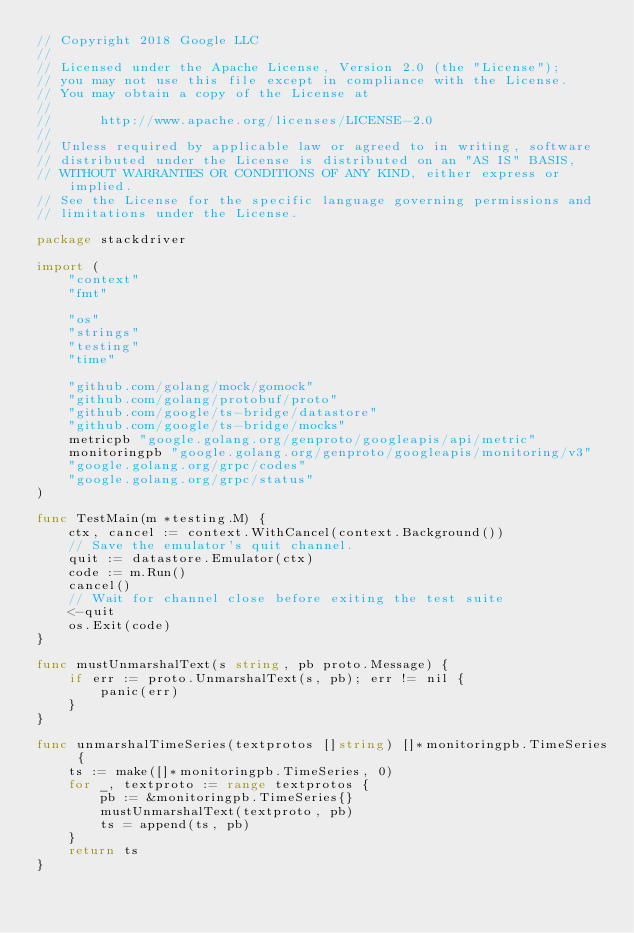<code> <loc_0><loc_0><loc_500><loc_500><_Go_>// Copyright 2018 Google LLC
//
// Licensed under the Apache License, Version 2.0 (the "License");
// you may not use this file except in compliance with the License.
// You may obtain a copy of the License at
//
//      http://www.apache.org/licenses/LICENSE-2.0
//
// Unless required by applicable law or agreed to in writing, software
// distributed under the License is distributed on an "AS IS" BASIS,
// WITHOUT WARRANTIES OR CONDITIONS OF ANY KIND, either express or implied.
// See the License for the specific language governing permissions and
// limitations under the License.

package stackdriver

import (
	"context"
	"fmt"

	"os"
	"strings"
	"testing"
	"time"

	"github.com/golang/mock/gomock"
	"github.com/golang/protobuf/proto"
	"github.com/google/ts-bridge/datastore"
	"github.com/google/ts-bridge/mocks"
	metricpb "google.golang.org/genproto/googleapis/api/metric"
	monitoringpb "google.golang.org/genproto/googleapis/monitoring/v3"
	"google.golang.org/grpc/codes"
	"google.golang.org/grpc/status"
)

func TestMain(m *testing.M) {
	ctx, cancel := context.WithCancel(context.Background())
	// Save the emulator's quit channel.
	quit := datastore.Emulator(ctx)
	code := m.Run()
	cancel()
	// Wait for channel close before exiting the test suite
	<-quit
	os.Exit(code)
}

func mustUnmarshalText(s string, pb proto.Message) {
	if err := proto.UnmarshalText(s, pb); err != nil {
		panic(err)
	}
}

func unmarshalTimeSeries(textprotos []string) []*monitoringpb.TimeSeries {
	ts := make([]*monitoringpb.TimeSeries, 0)
	for _, textproto := range textprotos {
		pb := &monitoringpb.TimeSeries{}
		mustUnmarshalText(textproto, pb)
		ts = append(ts, pb)
	}
	return ts
}
</code> 